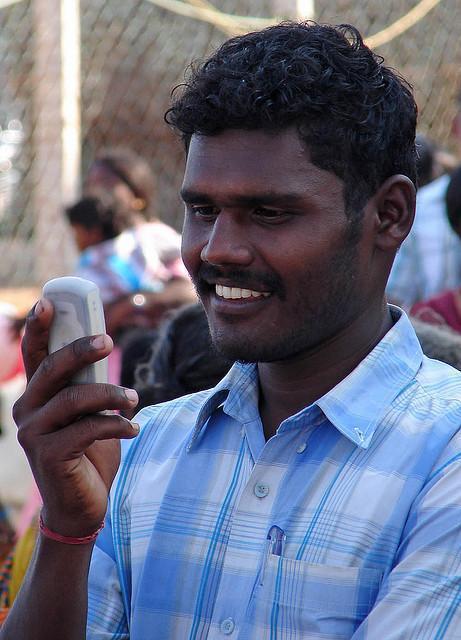How many people are there?
Give a very brief answer. 4. 